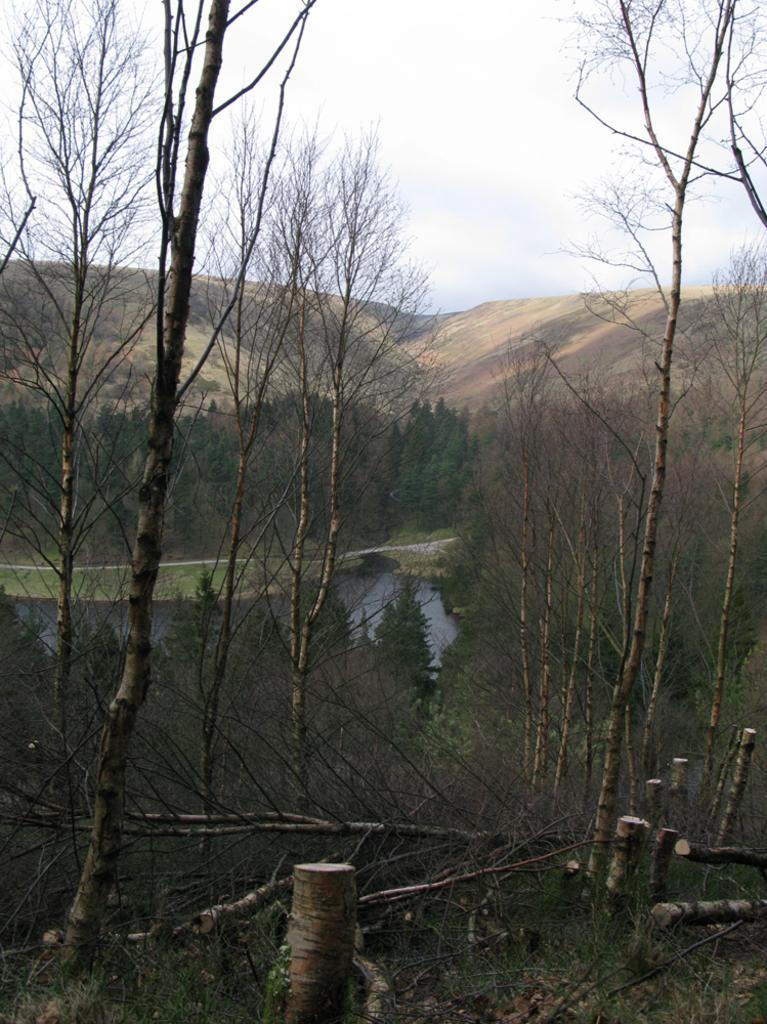How would you summarize this image in a sentence or two? This picture is taken from outside of the city. In this image, we can see some trees, plants, water in a lake, rocks. At the top, we can see a sky, at the bottom, we can see some wood poles, grass. 